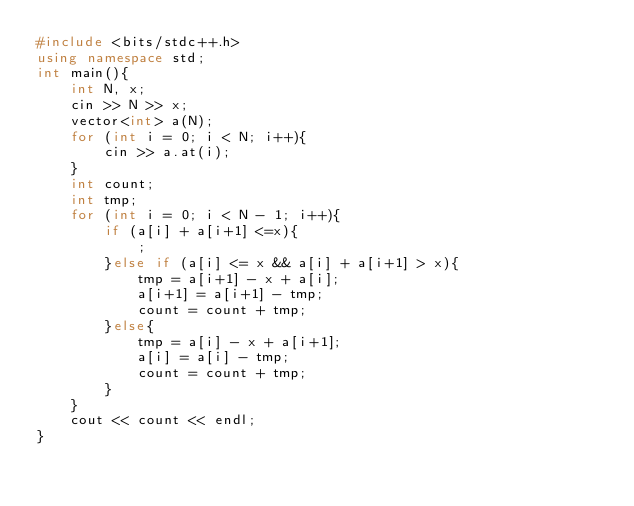Convert code to text. <code><loc_0><loc_0><loc_500><loc_500><_C++_>#include <bits/stdc++.h>
using namespace std;
int main(){
    int N, x;
    cin >> N >> x;
    vector<int> a(N);
    for (int i = 0; i < N; i++){
        cin >> a.at(i);
    }
    int count;
    int tmp;
    for (int i = 0; i < N - 1; i++){
        if (a[i] + a[i+1] <=x){
            ;
        }else if (a[i] <= x && a[i] + a[i+1] > x){
            tmp = a[i+1] - x + a[i];
            a[i+1] = a[i+1] - tmp;
            count = count + tmp;
        }else{
            tmp = a[i] - x + a[i+1];
            a[i] = a[i] - tmp;
            count = count + tmp;
        }
    }
    cout << count << endl;
}</code> 